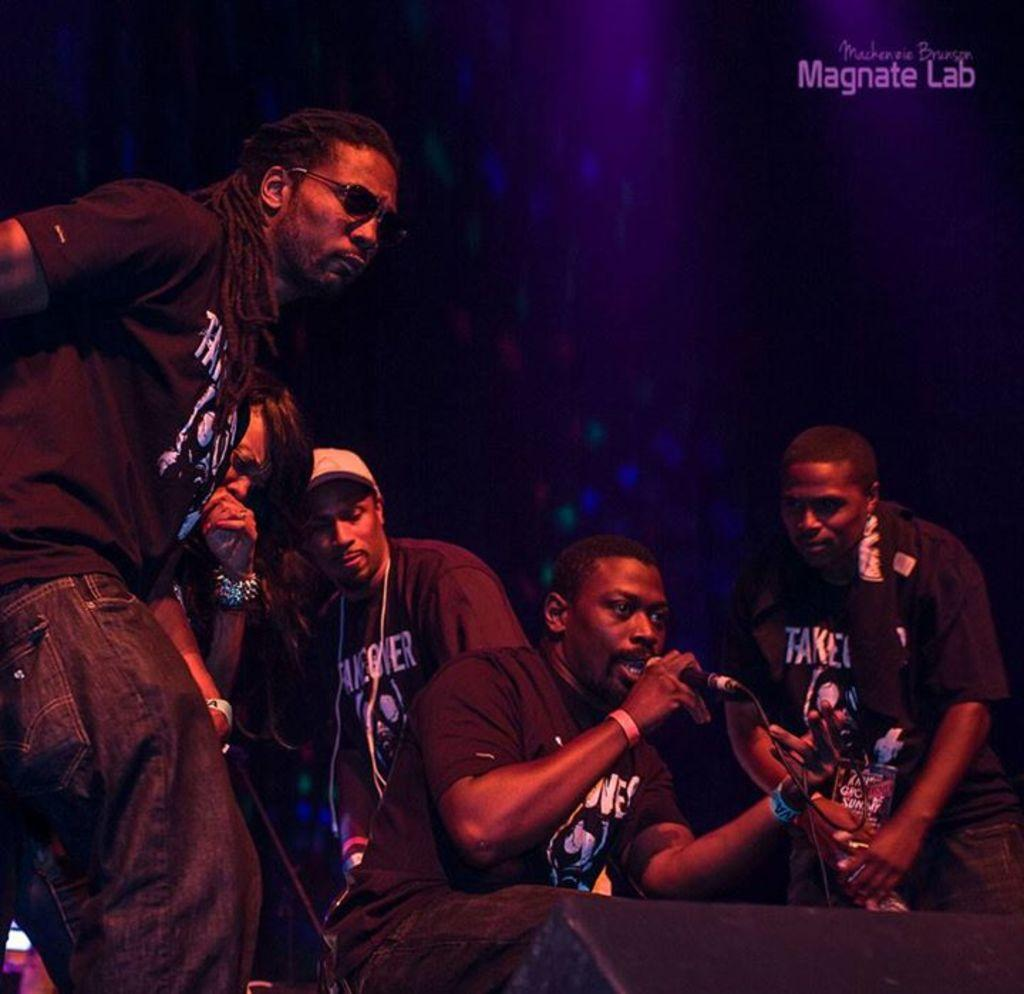What are the musicians in the image doing? The musicians in the image are singing. How are the musicians amplifying their voices in the image? The musicians are holding microphones. What can be seen in the background of the image? There is a designed wall in the background of the image. What words are written on the wall in the image? The words "Magnate lab" are written on the wall. What type of cake is being served to the passengers in the image? There is no cake or passengers present in the image; it features musicians singing and holding microphones. 